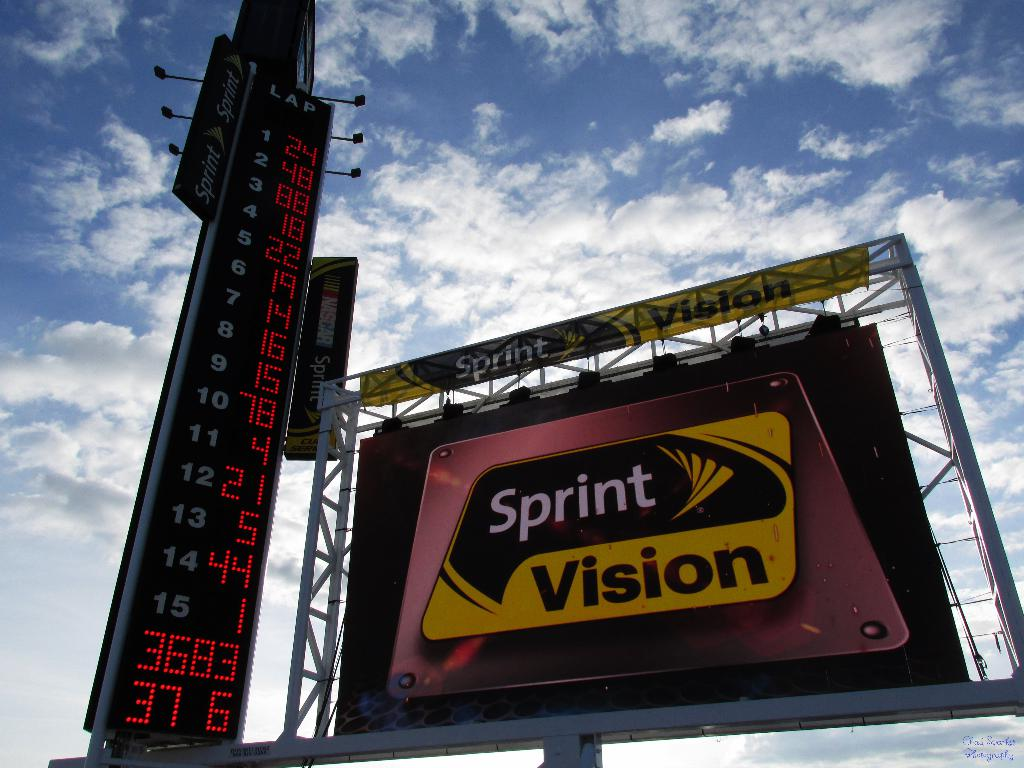Can you tell what specific event might be happening here based on the scoreboard and billboard details? The scoreboard displays time intervals and positions, typical indicators used in motor racing or similar speed sports. The appearance of 'Sprint Vision' on the billboard, along with its prominent techno-futuristic logo, hints at the event possibly being a car race, showcasing high speeds and technological enhancements. 